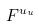Convert formula to latex. <formula><loc_0><loc_0><loc_500><loc_500>F ^ { u _ { u } }</formula> 